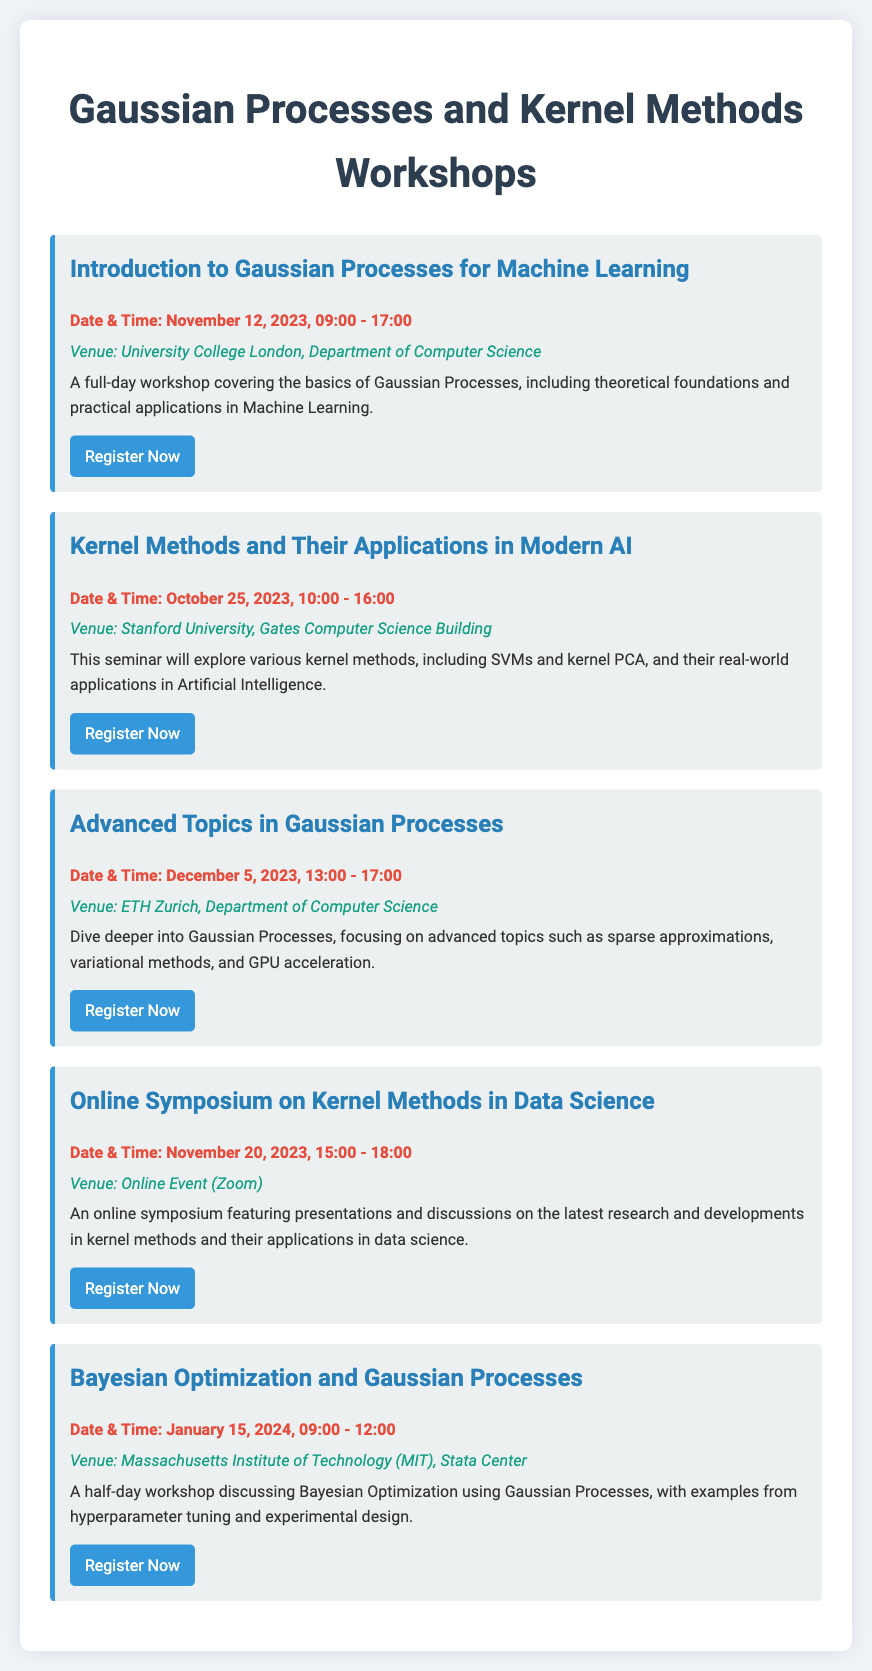What is the date and time of the workshop on Gaussian Processes? The workshop on Gaussian Processes is on November 12, 2023, from 09:00 to 17:00.
Answer: November 12, 2023, 09:00 - 17:00 Where will the Kernel Methods seminar be held? The Kernel Methods seminar will take place at Stanford University, Gates Computer Science Building.
Answer: Stanford University, Gates Computer Science Building What is the primary topic of the Advanced Topics in Gaussian Processes workshop? The primary topic is advanced topics such as sparse approximations, variational methods, and GPU acceleration.
Answer: Advanced topics such as sparse approximations, variational methods, and GPU acceleration When is the Online Symposium on Kernel Methods scheduled? The Online Symposium on Kernel Methods is scheduled for November 20, 2023, from 15:00 to 18:00.
Answer: November 20, 2023, 15:00 - 18:00 How long is the Bayesian Optimization workshop? The Bayesian Optimization workshop lasts for half a day, from 09:00 to 12:00.
Answer: Half-day, 09:00 - 12:00 